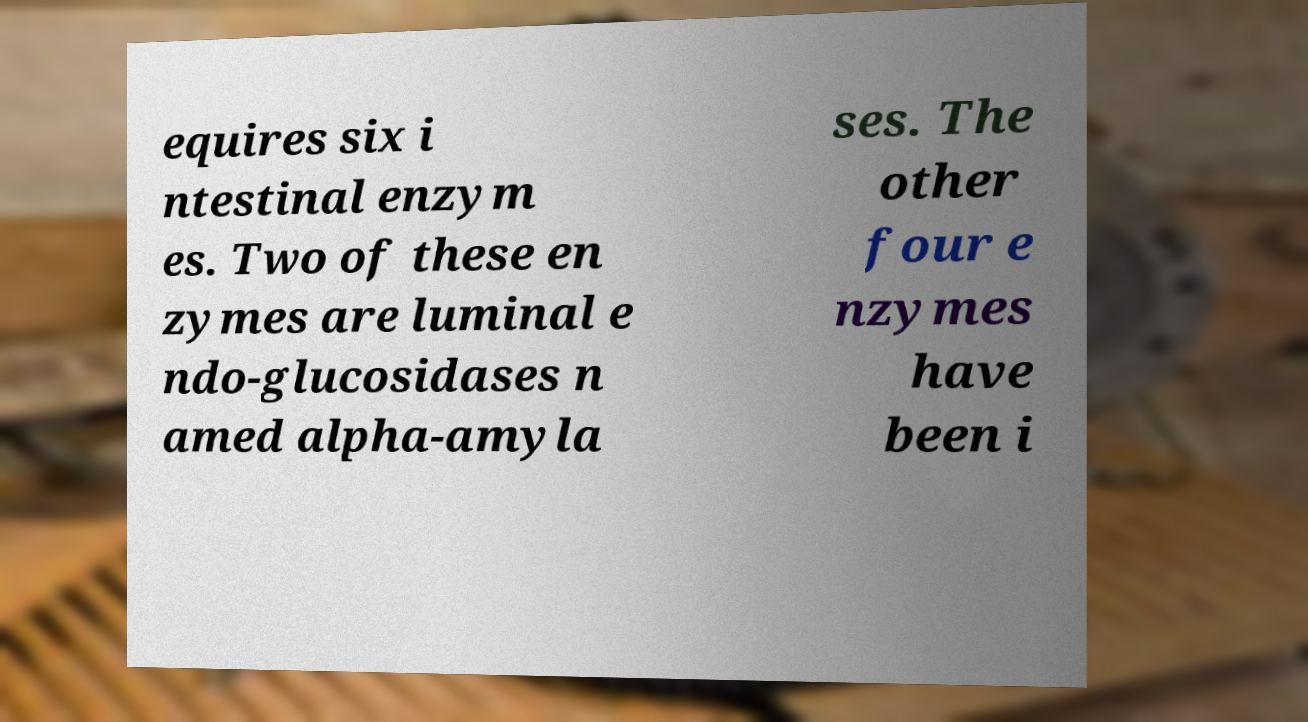I need the written content from this picture converted into text. Can you do that? equires six i ntestinal enzym es. Two of these en zymes are luminal e ndo-glucosidases n amed alpha-amyla ses. The other four e nzymes have been i 